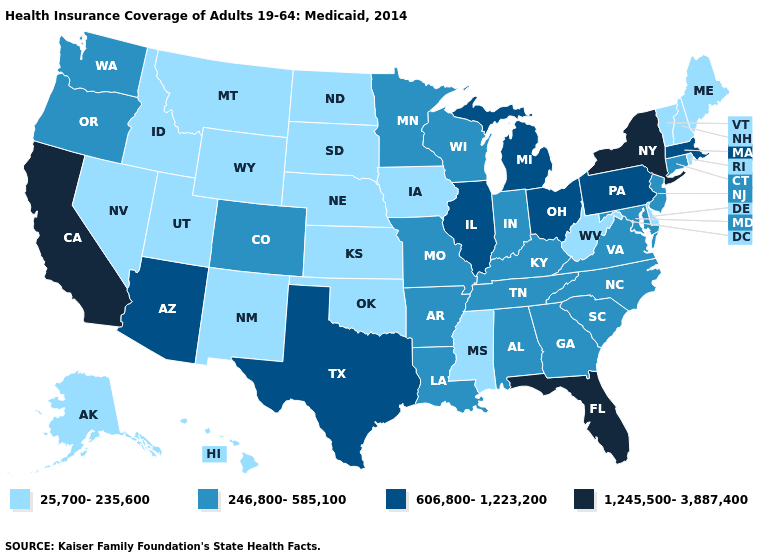Which states have the highest value in the USA?
Quick response, please. California, Florida, New York. Does Illinois have a higher value than Montana?
Quick response, please. Yes. What is the value of Montana?
Short answer required. 25,700-235,600. Does Maryland have the same value as Wisconsin?
Write a very short answer. Yes. How many symbols are there in the legend?
Give a very brief answer. 4. Name the states that have a value in the range 246,800-585,100?
Answer briefly. Alabama, Arkansas, Colorado, Connecticut, Georgia, Indiana, Kentucky, Louisiana, Maryland, Minnesota, Missouri, New Jersey, North Carolina, Oregon, South Carolina, Tennessee, Virginia, Washington, Wisconsin. Among the states that border Missouri , which have the lowest value?
Answer briefly. Iowa, Kansas, Nebraska, Oklahoma. Name the states that have a value in the range 25,700-235,600?
Quick response, please. Alaska, Delaware, Hawaii, Idaho, Iowa, Kansas, Maine, Mississippi, Montana, Nebraska, Nevada, New Hampshire, New Mexico, North Dakota, Oklahoma, Rhode Island, South Dakota, Utah, Vermont, West Virginia, Wyoming. What is the value of Florida?
Keep it brief. 1,245,500-3,887,400. Does the first symbol in the legend represent the smallest category?
Write a very short answer. Yes. Does Florida have the highest value in the South?
Concise answer only. Yes. Name the states that have a value in the range 25,700-235,600?
Write a very short answer. Alaska, Delaware, Hawaii, Idaho, Iowa, Kansas, Maine, Mississippi, Montana, Nebraska, Nevada, New Hampshire, New Mexico, North Dakota, Oklahoma, Rhode Island, South Dakota, Utah, Vermont, West Virginia, Wyoming. Does New Hampshire have a higher value than Rhode Island?
Be succinct. No. Which states have the lowest value in the USA?
Quick response, please. Alaska, Delaware, Hawaii, Idaho, Iowa, Kansas, Maine, Mississippi, Montana, Nebraska, Nevada, New Hampshire, New Mexico, North Dakota, Oklahoma, Rhode Island, South Dakota, Utah, Vermont, West Virginia, Wyoming. Name the states that have a value in the range 1,245,500-3,887,400?
Concise answer only. California, Florida, New York. 